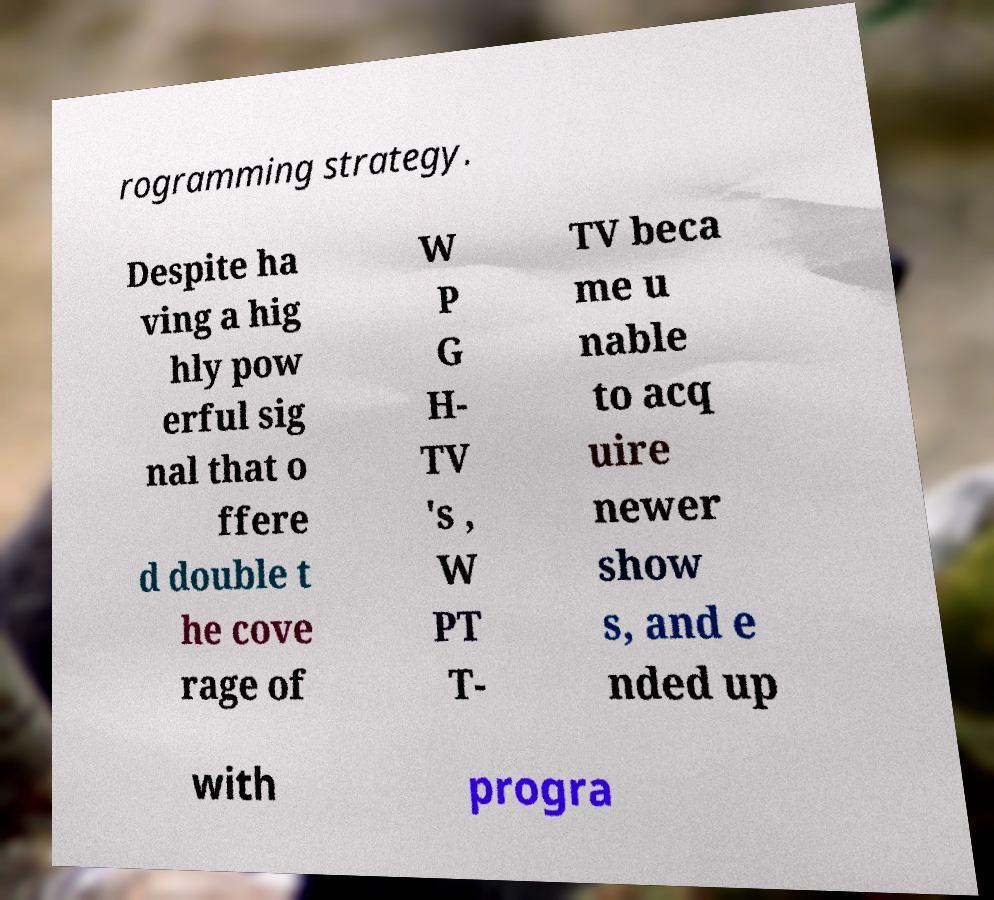Please read and relay the text visible in this image. What does it say? rogramming strategy. Despite ha ving a hig hly pow erful sig nal that o ffere d double t he cove rage of W P G H- TV 's , W PT T- TV beca me u nable to acq uire newer show s, and e nded up with progra 